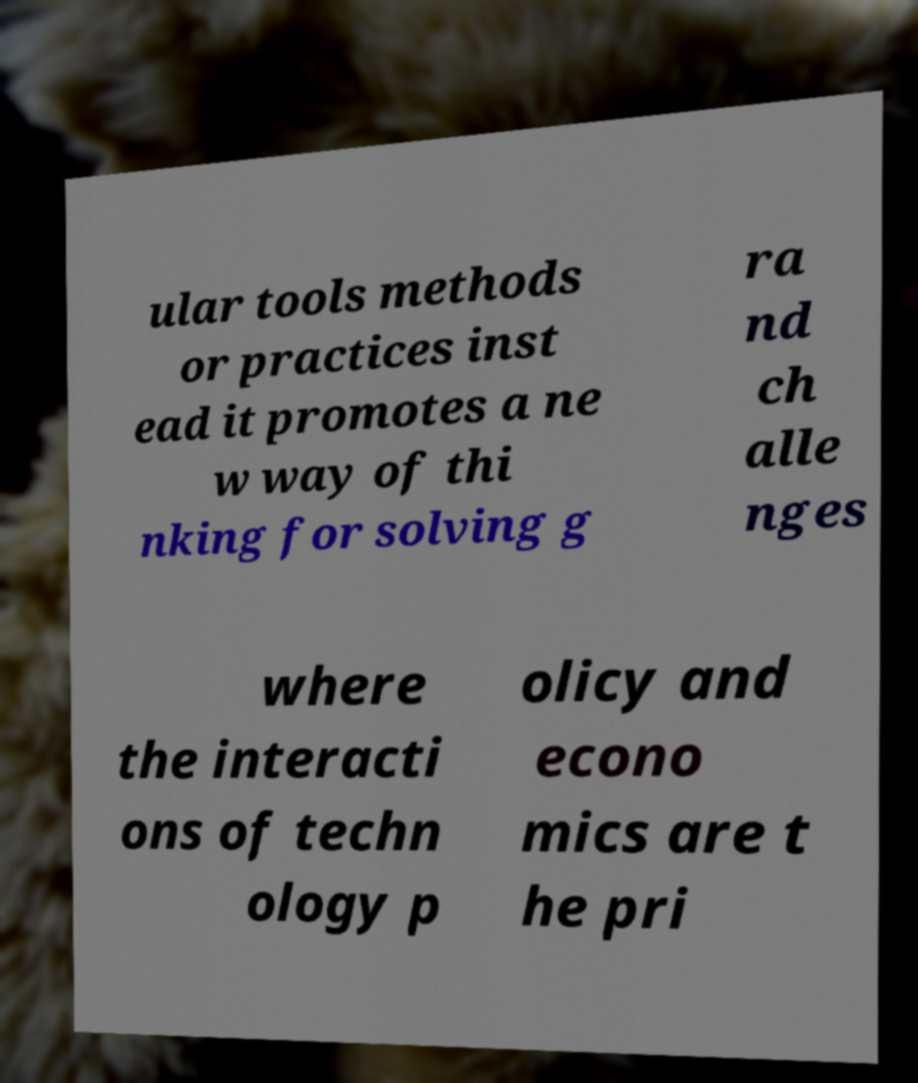I need the written content from this picture converted into text. Can you do that? ular tools methods or practices inst ead it promotes a ne w way of thi nking for solving g ra nd ch alle nges where the interacti ons of techn ology p olicy and econo mics are t he pri 